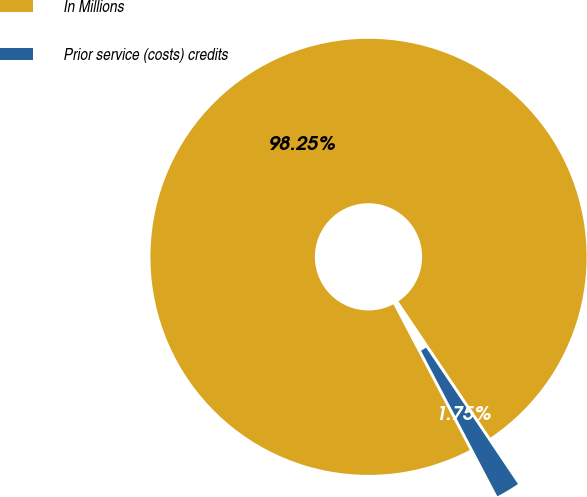<chart> <loc_0><loc_0><loc_500><loc_500><pie_chart><fcel>In Millions<fcel>Prior service (costs) credits<nl><fcel>98.25%<fcel>1.75%<nl></chart> 